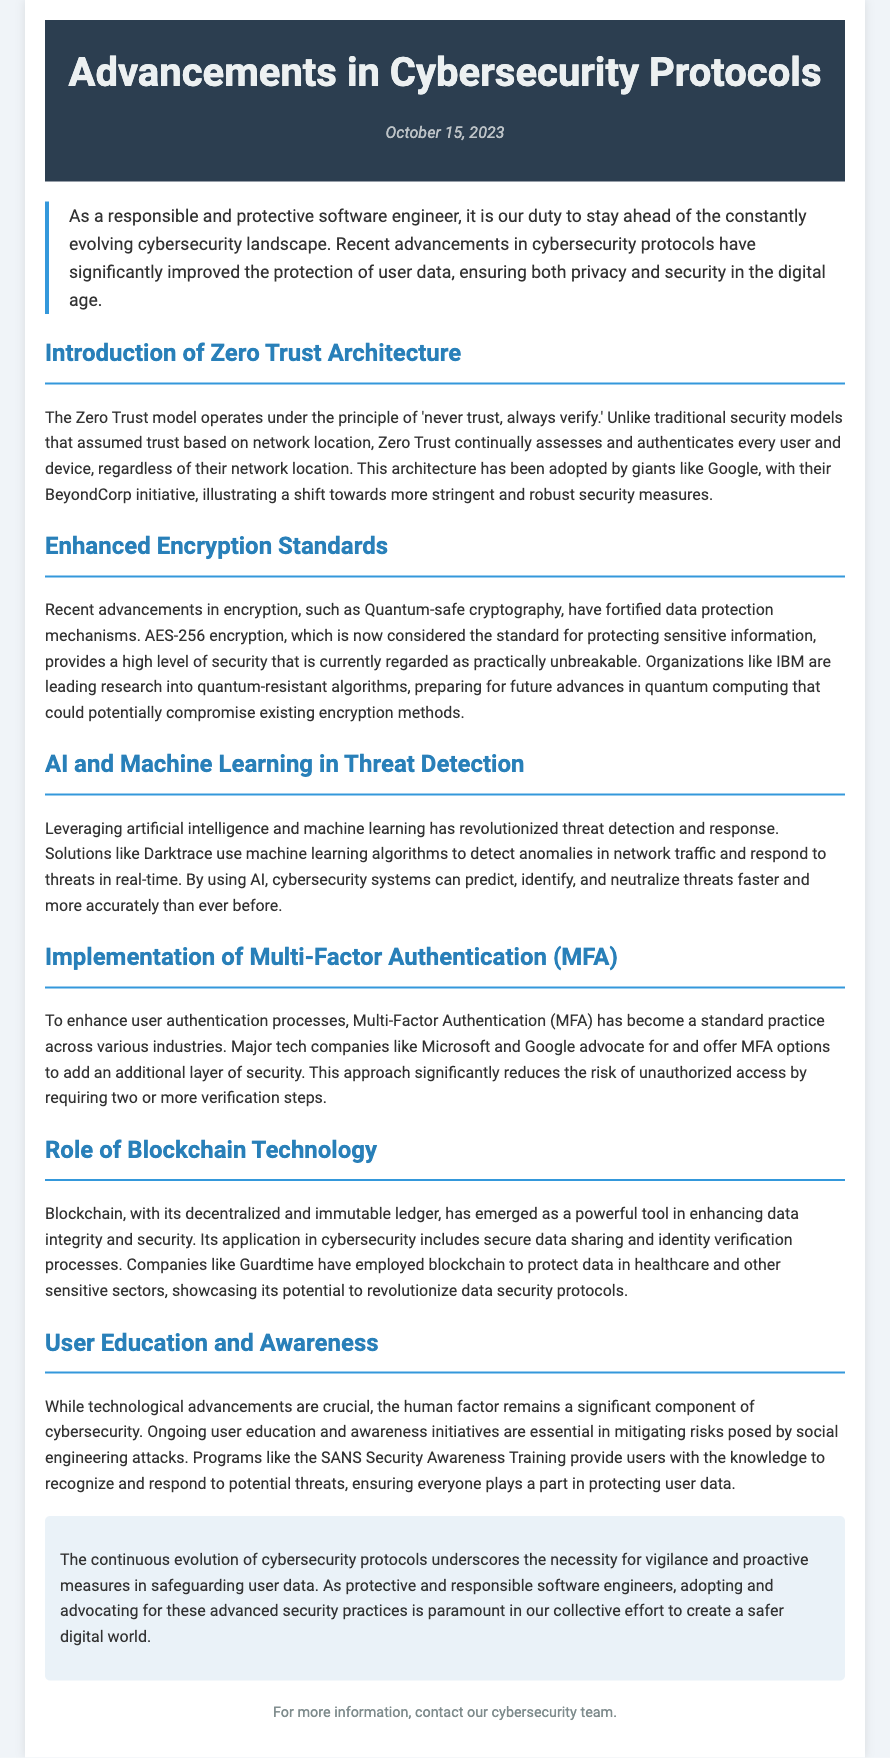What is the date of the press release? The date of the press release is explicitly stated as when the document was published.
Answer: October 15, 2023 What concept does Zero Trust Architecture operate under? The document defines the principle that guides the Zero Trust model.
Answer: never trust, always verify Which encryption standard is now considered the standard for protecting sensitive information? The press release clearly states what encryption standard is regarded as standard for data protection.
Answer: AES-256 Name a company that advocates for Multi-Factor Authentication. The document mentions specific tech companies promoting MFA to enhance security.
Answer: Microsoft What technology is highlighted for its role in enhancing data integrity and security? The press release discusses a specific technology known for its security capabilities.
Answer: Blockchain How does AI contribute to cybersecurity according to the document? The passage explains the impact of AI in threat detection and response processes.
Answer: revolutionized threat detection and response What is essential to mitigate risks posed by social engineering attacks? The text emphasizes a particular strategy to address human factors in cybersecurity.
Answer: Ongoing user education and awareness What initiative illustrates a shift towards stringent security measures? The document refers to a specific initiative adopted by a major company showcasing a shift in security practices.
Answer: BeyondCorp 